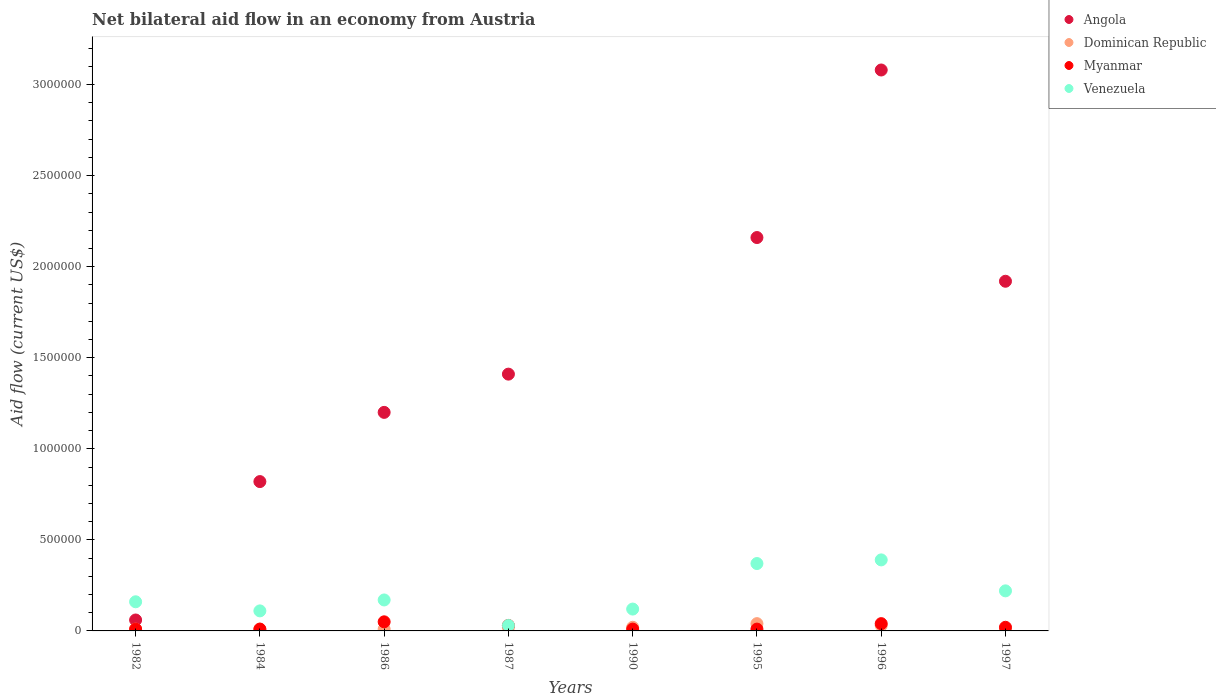Is the number of dotlines equal to the number of legend labels?
Give a very brief answer. No. What is the net bilateral aid flow in Venezuela in 1997?
Give a very brief answer. 2.20e+05. What is the total net bilateral aid flow in Myanmar in the graph?
Offer a terse response. 1.80e+05. What is the difference between the net bilateral aid flow in Angola in 1987 and that in 1997?
Give a very brief answer. -5.10e+05. What is the difference between the net bilateral aid flow in Dominican Republic in 1995 and the net bilateral aid flow in Angola in 1996?
Provide a succinct answer. -3.04e+06. What is the average net bilateral aid flow in Dominican Republic per year?
Offer a terse response. 1.88e+04. In the year 1984, what is the difference between the net bilateral aid flow in Dominican Republic and net bilateral aid flow in Angola?
Provide a short and direct response. -8.10e+05. In how many years, is the net bilateral aid flow in Angola greater than 2400000 US$?
Provide a succinct answer. 1. What is the ratio of the net bilateral aid flow in Angola in 1995 to that in 1996?
Your answer should be compact. 0.7. What is the difference between the highest and the second highest net bilateral aid flow in Myanmar?
Provide a succinct answer. 10000. What is the difference between the highest and the lowest net bilateral aid flow in Venezuela?
Ensure brevity in your answer.  3.60e+05. Is it the case that in every year, the sum of the net bilateral aid flow in Venezuela and net bilateral aid flow in Angola  is greater than the net bilateral aid flow in Dominican Republic?
Your answer should be compact. Yes. How many dotlines are there?
Ensure brevity in your answer.  4. Does the graph contain any zero values?
Provide a short and direct response. Yes. How are the legend labels stacked?
Your response must be concise. Vertical. What is the title of the graph?
Offer a terse response. Net bilateral aid flow in an economy from Austria. What is the label or title of the X-axis?
Your answer should be compact. Years. What is the label or title of the Y-axis?
Your response must be concise. Aid flow (current US$). What is the Aid flow (current US$) in Angola in 1982?
Provide a succinct answer. 6.00e+04. What is the Aid flow (current US$) in Dominican Republic in 1982?
Give a very brief answer. 10000. What is the Aid flow (current US$) of Venezuela in 1982?
Offer a very short reply. 1.60e+05. What is the Aid flow (current US$) in Angola in 1984?
Offer a terse response. 8.20e+05. What is the Aid flow (current US$) in Dominican Republic in 1984?
Your response must be concise. 10000. What is the Aid flow (current US$) in Angola in 1986?
Provide a succinct answer. 1.20e+06. What is the Aid flow (current US$) of Dominican Republic in 1986?
Provide a short and direct response. 10000. What is the Aid flow (current US$) of Myanmar in 1986?
Make the answer very short. 5.00e+04. What is the Aid flow (current US$) of Angola in 1987?
Your answer should be compact. 1.41e+06. What is the Aid flow (current US$) in Myanmar in 1987?
Keep it short and to the point. 3.00e+04. What is the Aid flow (current US$) in Venezuela in 1987?
Give a very brief answer. 3.00e+04. What is the Aid flow (current US$) in Angola in 1990?
Ensure brevity in your answer.  0. What is the Aid flow (current US$) in Venezuela in 1990?
Your answer should be very brief. 1.20e+05. What is the Aid flow (current US$) in Angola in 1995?
Offer a terse response. 2.16e+06. What is the Aid flow (current US$) of Angola in 1996?
Provide a succinct answer. 3.08e+06. What is the Aid flow (current US$) of Dominican Republic in 1996?
Make the answer very short. 3.00e+04. What is the Aid flow (current US$) in Myanmar in 1996?
Your answer should be compact. 4.00e+04. What is the Aid flow (current US$) in Angola in 1997?
Your answer should be very brief. 1.92e+06. What is the Aid flow (current US$) of Myanmar in 1997?
Your answer should be very brief. 2.00e+04. Across all years, what is the maximum Aid flow (current US$) of Angola?
Give a very brief answer. 3.08e+06. Across all years, what is the maximum Aid flow (current US$) in Myanmar?
Give a very brief answer. 5.00e+04. Across all years, what is the minimum Aid flow (current US$) of Dominican Republic?
Provide a succinct answer. 10000. What is the total Aid flow (current US$) in Angola in the graph?
Your response must be concise. 1.06e+07. What is the total Aid flow (current US$) of Dominican Republic in the graph?
Make the answer very short. 1.50e+05. What is the total Aid flow (current US$) of Venezuela in the graph?
Give a very brief answer. 1.57e+06. What is the difference between the Aid flow (current US$) of Angola in 1982 and that in 1984?
Make the answer very short. -7.60e+05. What is the difference between the Aid flow (current US$) in Dominican Republic in 1982 and that in 1984?
Offer a terse response. 0. What is the difference between the Aid flow (current US$) in Myanmar in 1982 and that in 1984?
Provide a short and direct response. 0. What is the difference between the Aid flow (current US$) in Venezuela in 1982 and that in 1984?
Offer a very short reply. 5.00e+04. What is the difference between the Aid flow (current US$) of Angola in 1982 and that in 1986?
Offer a very short reply. -1.14e+06. What is the difference between the Aid flow (current US$) in Dominican Republic in 1982 and that in 1986?
Your response must be concise. 0. What is the difference between the Aid flow (current US$) in Venezuela in 1982 and that in 1986?
Give a very brief answer. -10000. What is the difference between the Aid flow (current US$) in Angola in 1982 and that in 1987?
Your answer should be compact. -1.35e+06. What is the difference between the Aid flow (current US$) of Dominican Republic in 1982 and that in 1987?
Ensure brevity in your answer.  -10000. What is the difference between the Aid flow (current US$) in Venezuela in 1982 and that in 1987?
Your answer should be very brief. 1.30e+05. What is the difference between the Aid flow (current US$) in Venezuela in 1982 and that in 1990?
Your answer should be very brief. 4.00e+04. What is the difference between the Aid flow (current US$) in Angola in 1982 and that in 1995?
Your answer should be very brief. -2.10e+06. What is the difference between the Aid flow (current US$) of Myanmar in 1982 and that in 1995?
Give a very brief answer. 0. What is the difference between the Aid flow (current US$) of Angola in 1982 and that in 1996?
Your answer should be very brief. -3.02e+06. What is the difference between the Aid flow (current US$) in Dominican Republic in 1982 and that in 1996?
Give a very brief answer. -2.00e+04. What is the difference between the Aid flow (current US$) in Venezuela in 1982 and that in 1996?
Ensure brevity in your answer.  -2.30e+05. What is the difference between the Aid flow (current US$) in Angola in 1982 and that in 1997?
Give a very brief answer. -1.86e+06. What is the difference between the Aid flow (current US$) in Angola in 1984 and that in 1986?
Provide a short and direct response. -3.80e+05. What is the difference between the Aid flow (current US$) of Dominican Republic in 1984 and that in 1986?
Offer a very short reply. 0. What is the difference between the Aid flow (current US$) of Myanmar in 1984 and that in 1986?
Your answer should be compact. -4.00e+04. What is the difference between the Aid flow (current US$) of Angola in 1984 and that in 1987?
Offer a terse response. -5.90e+05. What is the difference between the Aid flow (current US$) of Dominican Republic in 1984 and that in 1987?
Ensure brevity in your answer.  -10000. What is the difference between the Aid flow (current US$) of Myanmar in 1984 and that in 1987?
Offer a very short reply. -2.00e+04. What is the difference between the Aid flow (current US$) of Angola in 1984 and that in 1995?
Your answer should be compact. -1.34e+06. What is the difference between the Aid flow (current US$) in Dominican Republic in 1984 and that in 1995?
Ensure brevity in your answer.  -3.00e+04. What is the difference between the Aid flow (current US$) of Venezuela in 1984 and that in 1995?
Your response must be concise. -2.60e+05. What is the difference between the Aid flow (current US$) of Angola in 1984 and that in 1996?
Ensure brevity in your answer.  -2.26e+06. What is the difference between the Aid flow (current US$) of Venezuela in 1984 and that in 1996?
Your response must be concise. -2.80e+05. What is the difference between the Aid flow (current US$) in Angola in 1984 and that in 1997?
Your answer should be very brief. -1.10e+06. What is the difference between the Aid flow (current US$) in Dominican Republic in 1984 and that in 1997?
Your response must be concise. 0. What is the difference between the Aid flow (current US$) of Dominican Republic in 1986 and that in 1987?
Your response must be concise. -10000. What is the difference between the Aid flow (current US$) in Myanmar in 1986 and that in 1987?
Provide a short and direct response. 2.00e+04. What is the difference between the Aid flow (current US$) in Venezuela in 1986 and that in 1990?
Your answer should be very brief. 5.00e+04. What is the difference between the Aid flow (current US$) in Angola in 1986 and that in 1995?
Your answer should be very brief. -9.60e+05. What is the difference between the Aid flow (current US$) of Angola in 1986 and that in 1996?
Give a very brief answer. -1.88e+06. What is the difference between the Aid flow (current US$) of Dominican Republic in 1986 and that in 1996?
Your answer should be compact. -2.00e+04. What is the difference between the Aid flow (current US$) in Angola in 1986 and that in 1997?
Your answer should be very brief. -7.20e+05. What is the difference between the Aid flow (current US$) of Dominican Republic in 1987 and that in 1990?
Ensure brevity in your answer.  0. What is the difference between the Aid flow (current US$) of Myanmar in 1987 and that in 1990?
Provide a short and direct response. 2.00e+04. What is the difference between the Aid flow (current US$) in Venezuela in 1987 and that in 1990?
Give a very brief answer. -9.00e+04. What is the difference between the Aid flow (current US$) of Angola in 1987 and that in 1995?
Provide a short and direct response. -7.50e+05. What is the difference between the Aid flow (current US$) in Dominican Republic in 1987 and that in 1995?
Provide a short and direct response. -2.00e+04. What is the difference between the Aid flow (current US$) of Myanmar in 1987 and that in 1995?
Provide a succinct answer. 2.00e+04. What is the difference between the Aid flow (current US$) in Venezuela in 1987 and that in 1995?
Offer a very short reply. -3.40e+05. What is the difference between the Aid flow (current US$) in Angola in 1987 and that in 1996?
Give a very brief answer. -1.67e+06. What is the difference between the Aid flow (current US$) of Dominican Republic in 1987 and that in 1996?
Give a very brief answer. -10000. What is the difference between the Aid flow (current US$) in Venezuela in 1987 and that in 1996?
Your answer should be very brief. -3.60e+05. What is the difference between the Aid flow (current US$) of Angola in 1987 and that in 1997?
Your answer should be very brief. -5.10e+05. What is the difference between the Aid flow (current US$) of Dominican Republic in 1990 and that in 1995?
Offer a terse response. -2.00e+04. What is the difference between the Aid flow (current US$) in Myanmar in 1990 and that in 1995?
Offer a terse response. 0. What is the difference between the Aid flow (current US$) in Venezuela in 1990 and that in 1996?
Your response must be concise. -2.70e+05. What is the difference between the Aid flow (current US$) in Myanmar in 1990 and that in 1997?
Give a very brief answer. -10000. What is the difference between the Aid flow (current US$) of Venezuela in 1990 and that in 1997?
Your response must be concise. -1.00e+05. What is the difference between the Aid flow (current US$) in Angola in 1995 and that in 1996?
Make the answer very short. -9.20e+05. What is the difference between the Aid flow (current US$) of Dominican Republic in 1995 and that in 1996?
Offer a very short reply. 10000. What is the difference between the Aid flow (current US$) of Myanmar in 1995 and that in 1996?
Ensure brevity in your answer.  -3.00e+04. What is the difference between the Aid flow (current US$) in Venezuela in 1995 and that in 1996?
Provide a succinct answer. -2.00e+04. What is the difference between the Aid flow (current US$) of Dominican Republic in 1995 and that in 1997?
Give a very brief answer. 3.00e+04. What is the difference between the Aid flow (current US$) in Angola in 1996 and that in 1997?
Ensure brevity in your answer.  1.16e+06. What is the difference between the Aid flow (current US$) of Venezuela in 1996 and that in 1997?
Your answer should be compact. 1.70e+05. What is the difference between the Aid flow (current US$) in Angola in 1982 and the Aid flow (current US$) in Dominican Republic in 1984?
Your answer should be very brief. 5.00e+04. What is the difference between the Aid flow (current US$) in Angola in 1982 and the Aid flow (current US$) in Myanmar in 1984?
Provide a succinct answer. 5.00e+04. What is the difference between the Aid flow (current US$) in Myanmar in 1982 and the Aid flow (current US$) in Venezuela in 1984?
Offer a terse response. -1.00e+05. What is the difference between the Aid flow (current US$) of Angola in 1982 and the Aid flow (current US$) of Dominican Republic in 1986?
Provide a short and direct response. 5.00e+04. What is the difference between the Aid flow (current US$) in Angola in 1982 and the Aid flow (current US$) in Myanmar in 1986?
Your response must be concise. 10000. What is the difference between the Aid flow (current US$) in Dominican Republic in 1982 and the Aid flow (current US$) in Myanmar in 1986?
Provide a short and direct response. -4.00e+04. What is the difference between the Aid flow (current US$) in Angola in 1982 and the Aid flow (current US$) in Venezuela in 1987?
Provide a short and direct response. 3.00e+04. What is the difference between the Aid flow (current US$) in Dominican Republic in 1982 and the Aid flow (current US$) in Venezuela in 1987?
Provide a succinct answer. -2.00e+04. What is the difference between the Aid flow (current US$) in Myanmar in 1982 and the Aid flow (current US$) in Venezuela in 1987?
Provide a short and direct response. -2.00e+04. What is the difference between the Aid flow (current US$) in Angola in 1982 and the Aid flow (current US$) in Dominican Republic in 1990?
Keep it short and to the point. 4.00e+04. What is the difference between the Aid flow (current US$) in Angola in 1982 and the Aid flow (current US$) in Myanmar in 1990?
Your answer should be compact. 5.00e+04. What is the difference between the Aid flow (current US$) in Angola in 1982 and the Aid flow (current US$) in Venezuela in 1990?
Give a very brief answer. -6.00e+04. What is the difference between the Aid flow (current US$) of Angola in 1982 and the Aid flow (current US$) of Dominican Republic in 1995?
Provide a succinct answer. 2.00e+04. What is the difference between the Aid flow (current US$) of Angola in 1982 and the Aid flow (current US$) of Myanmar in 1995?
Offer a very short reply. 5.00e+04. What is the difference between the Aid flow (current US$) of Angola in 1982 and the Aid flow (current US$) of Venezuela in 1995?
Your response must be concise. -3.10e+05. What is the difference between the Aid flow (current US$) in Dominican Republic in 1982 and the Aid flow (current US$) in Myanmar in 1995?
Your answer should be compact. 0. What is the difference between the Aid flow (current US$) in Dominican Republic in 1982 and the Aid flow (current US$) in Venezuela in 1995?
Provide a succinct answer. -3.60e+05. What is the difference between the Aid flow (current US$) in Myanmar in 1982 and the Aid flow (current US$) in Venezuela in 1995?
Your answer should be compact. -3.60e+05. What is the difference between the Aid flow (current US$) of Angola in 1982 and the Aid flow (current US$) of Dominican Republic in 1996?
Ensure brevity in your answer.  3.00e+04. What is the difference between the Aid flow (current US$) of Angola in 1982 and the Aid flow (current US$) of Venezuela in 1996?
Give a very brief answer. -3.30e+05. What is the difference between the Aid flow (current US$) of Dominican Republic in 1982 and the Aid flow (current US$) of Venezuela in 1996?
Ensure brevity in your answer.  -3.80e+05. What is the difference between the Aid flow (current US$) of Myanmar in 1982 and the Aid flow (current US$) of Venezuela in 1996?
Your response must be concise. -3.80e+05. What is the difference between the Aid flow (current US$) in Angola in 1982 and the Aid flow (current US$) in Dominican Republic in 1997?
Your response must be concise. 5.00e+04. What is the difference between the Aid flow (current US$) in Angola in 1982 and the Aid flow (current US$) in Venezuela in 1997?
Keep it short and to the point. -1.60e+05. What is the difference between the Aid flow (current US$) of Myanmar in 1982 and the Aid flow (current US$) of Venezuela in 1997?
Keep it short and to the point. -2.10e+05. What is the difference between the Aid flow (current US$) in Angola in 1984 and the Aid flow (current US$) in Dominican Republic in 1986?
Make the answer very short. 8.10e+05. What is the difference between the Aid flow (current US$) in Angola in 1984 and the Aid flow (current US$) in Myanmar in 1986?
Offer a terse response. 7.70e+05. What is the difference between the Aid flow (current US$) of Angola in 1984 and the Aid flow (current US$) of Venezuela in 1986?
Offer a very short reply. 6.50e+05. What is the difference between the Aid flow (current US$) in Dominican Republic in 1984 and the Aid flow (current US$) in Myanmar in 1986?
Ensure brevity in your answer.  -4.00e+04. What is the difference between the Aid flow (current US$) in Dominican Republic in 1984 and the Aid flow (current US$) in Venezuela in 1986?
Ensure brevity in your answer.  -1.60e+05. What is the difference between the Aid flow (current US$) in Myanmar in 1984 and the Aid flow (current US$) in Venezuela in 1986?
Offer a very short reply. -1.60e+05. What is the difference between the Aid flow (current US$) of Angola in 1984 and the Aid flow (current US$) of Myanmar in 1987?
Provide a succinct answer. 7.90e+05. What is the difference between the Aid flow (current US$) in Angola in 1984 and the Aid flow (current US$) in Venezuela in 1987?
Your answer should be compact. 7.90e+05. What is the difference between the Aid flow (current US$) in Dominican Republic in 1984 and the Aid flow (current US$) in Venezuela in 1987?
Provide a short and direct response. -2.00e+04. What is the difference between the Aid flow (current US$) of Angola in 1984 and the Aid flow (current US$) of Dominican Republic in 1990?
Keep it short and to the point. 8.00e+05. What is the difference between the Aid flow (current US$) of Angola in 1984 and the Aid flow (current US$) of Myanmar in 1990?
Provide a succinct answer. 8.10e+05. What is the difference between the Aid flow (current US$) in Angola in 1984 and the Aid flow (current US$) in Venezuela in 1990?
Your answer should be compact. 7.00e+05. What is the difference between the Aid flow (current US$) in Dominican Republic in 1984 and the Aid flow (current US$) in Myanmar in 1990?
Your answer should be very brief. 0. What is the difference between the Aid flow (current US$) of Angola in 1984 and the Aid flow (current US$) of Dominican Republic in 1995?
Provide a short and direct response. 7.80e+05. What is the difference between the Aid flow (current US$) in Angola in 1984 and the Aid flow (current US$) in Myanmar in 1995?
Give a very brief answer. 8.10e+05. What is the difference between the Aid flow (current US$) of Dominican Republic in 1984 and the Aid flow (current US$) of Myanmar in 1995?
Offer a very short reply. 0. What is the difference between the Aid flow (current US$) in Dominican Republic in 1984 and the Aid flow (current US$) in Venezuela in 1995?
Your answer should be compact. -3.60e+05. What is the difference between the Aid flow (current US$) of Myanmar in 1984 and the Aid flow (current US$) of Venezuela in 1995?
Your response must be concise. -3.60e+05. What is the difference between the Aid flow (current US$) of Angola in 1984 and the Aid flow (current US$) of Dominican Republic in 1996?
Provide a succinct answer. 7.90e+05. What is the difference between the Aid flow (current US$) of Angola in 1984 and the Aid flow (current US$) of Myanmar in 1996?
Your answer should be compact. 7.80e+05. What is the difference between the Aid flow (current US$) in Dominican Republic in 1984 and the Aid flow (current US$) in Myanmar in 1996?
Give a very brief answer. -3.00e+04. What is the difference between the Aid flow (current US$) in Dominican Republic in 1984 and the Aid flow (current US$) in Venezuela in 1996?
Ensure brevity in your answer.  -3.80e+05. What is the difference between the Aid flow (current US$) of Myanmar in 1984 and the Aid flow (current US$) of Venezuela in 1996?
Give a very brief answer. -3.80e+05. What is the difference between the Aid flow (current US$) in Angola in 1984 and the Aid flow (current US$) in Dominican Republic in 1997?
Give a very brief answer. 8.10e+05. What is the difference between the Aid flow (current US$) of Angola in 1984 and the Aid flow (current US$) of Myanmar in 1997?
Offer a very short reply. 8.00e+05. What is the difference between the Aid flow (current US$) of Angola in 1984 and the Aid flow (current US$) of Venezuela in 1997?
Offer a very short reply. 6.00e+05. What is the difference between the Aid flow (current US$) in Angola in 1986 and the Aid flow (current US$) in Dominican Republic in 1987?
Offer a terse response. 1.18e+06. What is the difference between the Aid flow (current US$) in Angola in 1986 and the Aid flow (current US$) in Myanmar in 1987?
Your answer should be compact. 1.17e+06. What is the difference between the Aid flow (current US$) of Angola in 1986 and the Aid flow (current US$) of Venezuela in 1987?
Keep it short and to the point. 1.17e+06. What is the difference between the Aid flow (current US$) of Dominican Republic in 1986 and the Aid flow (current US$) of Venezuela in 1987?
Keep it short and to the point. -2.00e+04. What is the difference between the Aid flow (current US$) of Myanmar in 1986 and the Aid flow (current US$) of Venezuela in 1987?
Make the answer very short. 2.00e+04. What is the difference between the Aid flow (current US$) of Angola in 1986 and the Aid flow (current US$) of Dominican Republic in 1990?
Keep it short and to the point. 1.18e+06. What is the difference between the Aid flow (current US$) in Angola in 1986 and the Aid flow (current US$) in Myanmar in 1990?
Keep it short and to the point. 1.19e+06. What is the difference between the Aid flow (current US$) of Angola in 1986 and the Aid flow (current US$) of Venezuela in 1990?
Your answer should be compact. 1.08e+06. What is the difference between the Aid flow (current US$) in Dominican Republic in 1986 and the Aid flow (current US$) in Myanmar in 1990?
Your answer should be compact. 0. What is the difference between the Aid flow (current US$) of Angola in 1986 and the Aid flow (current US$) of Dominican Republic in 1995?
Give a very brief answer. 1.16e+06. What is the difference between the Aid flow (current US$) in Angola in 1986 and the Aid flow (current US$) in Myanmar in 1995?
Your answer should be very brief. 1.19e+06. What is the difference between the Aid flow (current US$) in Angola in 1986 and the Aid flow (current US$) in Venezuela in 1995?
Offer a terse response. 8.30e+05. What is the difference between the Aid flow (current US$) in Dominican Republic in 1986 and the Aid flow (current US$) in Myanmar in 1995?
Ensure brevity in your answer.  0. What is the difference between the Aid flow (current US$) in Dominican Republic in 1986 and the Aid flow (current US$) in Venezuela in 1995?
Ensure brevity in your answer.  -3.60e+05. What is the difference between the Aid flow (current US$) in Myanmar in 1986 and the Aid flow (current US$) in Venezuela in 1995?
Offer a terse response. -3.20e+05. What is the difference between the Aid flow (current US$) of Angola in 1986 and the Aid flow (current US$) of Dominican Republic in 1996?
Your response must be concise. 1.17e+06. What is the difference between the Aid flow (current US$) of Angola in 1986 and the Aid flow (current US$) of Myanmar in 1996?
Your answer should be very brief. 1.16e+06. What is the difference between the Aid flow (current US$) in Angola in 1986 and the Aid flow (current US$) in Venezuela in 1996?
Ensure brevity in your answer.  8.10e+05. What is the difference between the Aid flow (current US$) in Dominican Republic in 1986 and the Aid flow (current US$) in Myanmar in 1996?
Give a very brief answer. -3.00e+04. What is the difference between the Aid flow (current US$) in Dominican Republic in 1986 and the Aid flow (current US$) in Venezuela in 1996?
Offer a very short reply. -3.80e+05. What is the difference between the Aid flow (current US$) in Myanmar in 1986 and the Aid flow (current US$) in Venezuela in 1996?
Your answer should be compact. -3.40e+05. What is the difference between the Aid flow (current US$) of Angola in 1986 and the Aid flow (current US$) of Dominican Republic in 1997?
Keep it short and to the point. 1.19e+06. What is the difference between the Aid flow (current US$) in Angola in 1986 and the Aid flow (current US$) in Myanmar in 1997?
Your answer should be very brief. 1.18e+06. What is the difference between the Aid flow (current US$) of Angola in 1986 and the Aid flow (current US$) of Venezuela in 1997?
Provide a succinct answer. 9.80e+05. What is the difference between the Aid flow (current US$) of Dominican Republic in 1986 and the Aid flow (current US$) of Myanmar in 1997?
Offer a terse response. -10000. What is the difference between the Aid flow (current US$) of Angola in 1987 and the Aid flow (current US$) of Dominican Republic in 1990?
Your answer should be very brief. 1.39e+06. What is the difference between the Aid flow (current US$) of Angola in 1987 and the Aid flow (current US$) of Myanmar in 1990?
Your answer should be compact. 1.40e+06. What is the difference between the Aid flow (current US$) in Angola in 1987 and the Aid flow (current US$) in Venezuela in 1990?
Make the answer very short. 1.29e+06. What is the difference between the Aid flow (current US$) of Angola in 1987 and the Aid flow (current US$) of Dominican Republic in 1995?
Ensure brevity in your answer.  1.37e+06. What is the difference between the Aid flow (current US$) in Angola in 1987 and the Aid flow (current US$) in Myanmar in 1995?
Give a very brief answer. 1.40e+06. What is the difference between the Aid flow (current US$) in Angola in 1987 and the Aid flow (current US$) in Venezuela in 1995?
Ensure brevity in your answer.  1.04e+06. What is the difference between the Aid flow (current US$) in Dominican Republic in 1987 and the Aid flow (current US$) in Venezuela in 1995?
Keep it short and to the point. -3.50e+05. What is the difference between the Aid flow (current US$) of Myanmar in 1987 and the Aid flow (current US$) of Venezuela in 1995?
Your answer should be compact. -3.40e+05. What is the difference between the Aid flow (current US$) in Angola in 1987 and the Aid flow (current US$) in Dominican Republic in 1996?
Give a very brief answer. 1.38e+06. What is the difference between the Aid flow (current US$) in Angola in 1987 and the Aid flow (current US$) in Myanmar in 1996?
Provide a short and direct response. 1.37e+06. What is the difference between the Aid flow (current US$) of Angola in 1987 and the Aid flow (current US$) of Venezuela in 1996?
Your response must be concise. 1.02e+06. What is the difference between the Aid flow (current US$) of Dominican Republic in 1987 and the Aid flow (current US$) of Venezuela in 1996?
Provide a short and direct response. -3.70e+05. What is the difference between the Aid flow (current US$) of Myanmar in 1987 and the Aid flow (current US$) of Venezuela in 1996?
Make the answer very short. -3.60e+05. What is the difference between the Aid flow (current US$) of Angola in 1987 and the Aid flow (current US$) of Dominican Republic in 1997?
Your response must be concise. 1.40e+06. What is the difference between the Aid flow (current US$) in Angola in 1987 and the Aid flow (current US$) in Myanmar in 1997?
Your answer should be very brief. 1.39e+06. What is the difference between the Aid flow (current US$) in Angola in 1987 and the Aid flow (current US$) in Venezuela in 1997?
Keep it short and to the point. 1.19e+06. What is the difference between the Aid flow (current US$) of Dominican Republic in 1987 and the Aid flow (current US$) of Myanmar in 1997?
Provide a succinct answer. 0. What is the difference between the Aid flow (current US$) of Dominican Republic in 1987 and the Aid flow (current US$) of Venezuela in 1997?
Ensure brevity in your answer.  -2.00e+05. What is the difference between the Aid flow (current US$) of Myanmar in 1987 and the Aid flow (current US$) of Venezuela in 1997?
Give a very brief answer. -1.90e+05. What is the difference between the Aid flow (current US$) in Dominican Republic in 1990 and the Aid flow (current US$) in Myanmar in 1995?
Give a very brief answer. 10000. What is the difference between the Aid flow (current US$) in Dominican Republic in 1990 and the Aid flow (current US$) in Venezuela in 1995?
Keep it short and to the point. -3.50e+05. What is the difference between the Aid flow (current US$) in Myanmar in 1990 and the Aid flow (current US$) in Venezuela in 1995?
Your answer should be compact. -3.60e+05. What is the difference between the Aid flow (current US$) in Dominican Republic in 1990 and the Aid flow (current US$) in Myanmar in 1996?
Provide a succinct answer. -2.00e+04. What is the difference between the Aid flow (current US$) in Dominican Republic in 1990 and the Aid flow (current US$) in Venezuela in 1996?
Offer a terse response. -3.70e+05. What is the difference between the Aid flow (current US$) in Myanmar in 1990 and the Aid flow (current US$) in Venezuela in 1996?
Make the answer very short. -3.80e+05. What is the difference between the Aid flow (current US$) of Dominican Republic in 1990 and the Aid flow (current US$) of Venezuela in 1997?
Make the answer very short. -2.00e+05. What is the difference between the Aid flow (current US$) of Myanmar in 1990 and the Aid flow (current US$) of Venezuela in 1997?
Offer a terse response. -2.10e+05. What is the difference between the Aid flow (current US$) of Angola in 1995 and the Aid flow (current US$) of Dominican Republic in 1996?
Offer a very short reply. 2.13e+06. What is the difference between the Aid flow (current US$) in Angola in 1995 and the Aid flow (current US$) in Myanmar in 1996?
Provide a succinct answer. 2.12e+06. What is the difference between the Aid flow (current US$) in Angola in 1995 and the Aid flow (current US$) in Venezuela in 1996?
Your answer should be compact. 1.77e+06. What is the difference between the Aid flow (current US$) of Dominican Republic in 1995 and the Aid flow (current US$) of Myanmar in 1996?
Provide a short and direct response. 0. What is the difference between the Aid flow (current US$) in Dominican Republic in 1995 and the Aid flow (current US$) in Venezuela in 1996?
Offer a very short reply. -3.50e+05. What is the difference between the Aid flow (current US$) in Myanmar in 1995 and the Aid flow (current US$) in Venezuela in 1996?
Keep it short and to the point. -3.80e+05. What is the difference between the Aid flow (current US$) of Angola in 1995 and the Aid flow (current US$) of Dominican Republic in 1997?
Offer a terse response. 2.15e+06. What is the difference between the Aid flow (current US$) in Angola in 1995 and the Aid flow (current US$) in Myanmar in 1997?
Provide a succinct answer. 2.14e+06. What is the difference between the Aid flow (current US$) in Angola in 1995 and the Aid flow (current US$) in Venezuela in 1997?
Ensure brevity in your answer.  1.94e+06. What is the difference between the Aid flow (current US$) of Dominican Republic in 1995 and the Aid flow (current US$) of Myanmar in 1997?
Offer a very short reply. 2.00e+04. What is the difference between the Aid flow (current US$) in Myanmar in 1995 and the Aid flow (current US$) in Venezuela in 1997?
Your answer should be very brief. -2.10e+05. What is the difference between the Aid flow (current US$) in Angola in 1996 and the Aid flow (current US$) in Dominican Republic in 1997?
Offer a very short reply. 3.07e+06. What is the difference between the Aid flow (current US$) in Angola in 1996 and the Aid flow (current US$) in Myanmar in 1997?
Offer a very short reply. 3.06e+06. What is the difference between the Aid flow (current US$) in Angola in 1996 and the Aid flow (current US$) in Venezuela in 1997?
Keep it short and to the point. 2.86e+06. What is the difference between the Aid flow (current US$) of Dominican Republic in 1996 and the Aid flow (current US$) of Venezuela in 1997?
Offer a terse response. -1.90e+05. What is the difference between the Aid flow (current US$) in Myanmar in 1996 and the Aid flow (current US$) in Venezuela in 1997?
Offer a very short reply. -1.80e+05. What is the average Aid flow (current US$) of Angola per year?
Offer a very short reply. 1.33e+06. What is the average Aid flow (current US$) in Dominican Republic per year?
Offer a very short reply. 1.88e+04. What is the average Aid flow (current US$) in Myanmar per year?
Offer a terse response. 2.25e+04. What is the average Aid flow (current US$) in Venezuela per year?
Keep it short and to the point. 1.96e+05. In the year 1982, what is the difference between the Aid flow (current US$) of Angola and Aid flow (current US$) of Myanmar?
Keep it short and to the point. 5.00e+04. In the year 1984, what is the difference between the Aid flow (current US$) in Angola and Aid flow (current US$) in Dominican Republic?
Offer a terse response. 8.10e+05. In the year 1984, what is the difference between the Aid flow (current US$) of Angola and Aid flow (current US$) of Myanmar?
Offer a terse response. 8.10e+05. In the year 1984, what is the difference between the Aid flow (current US$) in Angola and Aid flow (current US$) in Venezuela?
Offer a very short reply. 7.10e+05. In the year 1984, what is the difference between the Aid flow (current US$) in Dominican Republic and Aid flow (current US$) in Venezuela?
Offer a terse response. -1.00e+05. In the year 1986, what is the difference between the Aid flow (current US$) of Angola and Aid flow (current US$) of Dominican Republic?
Ensure brevity in your answer.  1.19e+06. In the year 1986, what is the difference between the Aid flow (current US$) in Angola and Aid flow (current US$) in Myanmar?
Your answer should be very brief. 1.15e+06. In the year 1986, what is the difference between the Aid flow (current US$) of Angola and Aid flow (current US$) of Venezuela?
Keep it short and to the point. 1.03e+06. In the year 1986, what is the difference between the Aid flow (current US$) of Dominican Republic and Aid flow (current US$) of Myanmar?
Make the answer very short. -4.00e+04. In the year 1986, what is the difference between the Aid flow (current US$) of Dominican Republic and Aid flow (current US$) of Venezuela?
Your answer should be compact. -1.60e+05. In the year 1986, what is the difference between the Aid flow (current US$) in Myanmar and Aid flow (current US$) in Venezuela?
Offer a terse response. -1.20e+05. In the year 1987, what is the difference between the Aid flow (current US$) in Angola and Aid flow (current US$) in Dominican Republic?
Make the answer very short. 1.39e+06. In the year 1987, what is the difference between the Aid flow (current US$) in Angola and Aid flow (current US$) in Myanmar?
Provide a succinct answer. 1.38e+06. In the year 1987, what is the difference between the Aid flow (current US$) of Angola and Aid flow (current US$) of Venezuela?
Ensure brevity in your answer.  1.38e+06. In the year 1987, what is the difference between the Aid flow (current US$) of Myanmar and Aid flow (current US$) of Venezuela?
Make the answer very short. 0. In the year 1990, what is the difference between the Aid flow (current US$) in Dominican Republic and Aid flow (current US$) in Myanmar?
Make the answer very short. 10000. In the year 1990, what is the difference between the Aid flow (current US$) of Dominican Republic and Aid flow (current US$) of Venezuela?
Make the answer very short. -1.00e+05. In the year 1990, what is the difference between the Aid flow (current US$) in Myanmar and Aid flow (current US$) in Venezuela?
Give a very brief answer. -1.10e+05. In the year 1995, what is the difference between the Aid flow (current US$) in Angola and Aid flow (current US$) in Dominican Republic?
Your answer should be compact. 2.12e+06. In the year 1995, what is the difference between the Aid flow (current US$) in Angola and Aid flow (current US$) in Myanmar?
Your response must be concise. 2.15e+06. In the year 1995, what is the difference between the Aid flow (current US$) of Angola and Aid flow (current US$) of Venezuela?
Provide a short and direct response. 1.79e+06. In the year 1995, what is the difference between the Aid flow (current US$) of Dominican Republic and Aid flow (current US$) of Myanmar?
Your response must be concise. 3.00e+04. In the year 1995, what is the difference between the Aid flow (current US$) of Dominican Republic and Aid flow (current US$) of Venezuela?
Your response must be concise. -3.30e+05. In the year 1995, what is the difference between the Aid flow (current US$) of Myanmar and Aid flow (current US$) of Venezuela?
Give a very brief answer. -3.60e+05. In the year 1996, what is the difference between the Aid flow (current US$) in Angola and Aid flow (current US$) in Dominican Republic?
Provide a short and direct response. 3.05e+06. In the year 1996, what is the difference between the Aid flow (current US$) of Angola and Aid flow (current US$) of Myanmar?
Provide a short and direct response. 3.04e+06. In the year 1996, what is the difference between the Aid flow (current US$) of Angola and Aid flow (current US$) of Venezuela?
Provide a short and direct response. 2.69e+06. In the year 1996, what is the difference between the Aid flow (current US$) in Dominican Republic and Aid flow (current US$) in Myanmar?
Offer a very short reply. -10000. In the year 1996, what is the difference between the Aid flow (current US$) in Dominican Republic and Aid flow (current US$) in Venezuela?
Offer a terse response. -3.60e+05. In the year 1996, what is the difference between the Aid flow (current US$) in Myanmar and Aid flow (current US$) in Venezuela?
Offer a very short reply. -3.50e+05. In the year 1997, what is the difference between the Aid flow (current US$) in Angola and Aid flow (current US$) in Dominican Republic?
Offer a terse response. 1.91e+06. In the year 1997, what is the difference between the Aid flow (current US$) in Angola and Aid flow (current US$) in Myanmar?
Give a very brief answer. 1.90e+06. In the year 1997, what is the difference between the Aid flow (current US$) in Angola and Aid flow (current US$) in Venezuela?
Your response must be concise. 1.70e+06. In the year 1997, what is the difference between the Aid flow (current US$) in Dominican Republic and Aid flow (current US$) in Venezuela?
Your answer should be very brief. -2.10e+05. In the year 1997, what is the difference between the Aid flow (current US$) in Myanmar and Aid flow (current US$) in Venezuela?
Your answer should be very brief. -2.00e+05. What is the ratio of the Aid flow (current US$) in Angola in 1982 to that in 1984?
Give a very brief answer. 0.07. What is the ratio of the Aid flow (current US$) of Dominican Republic in 1982 to that in 1984?
Your answer should be compact. 1. What is the ratio of the Aid flow (current US$) of Myanmar in 1982 to that in 1984?
Offer a terse response. 1. What is the ratio of the Aid flow (current US$) in Venezuela in 1982 to that in 1984?
Ensure brevity in your answer.  1.45. What is the ratio of the Aid flow (current US$) of Angola in 1982 to that in 1986?
Ensure brevity in your answer.  0.05. What is the ratio of the Aid flow (current US$) in Dominican Republic in 1982 to that in 1986?
Your answer should be compact. 1. What is the ratio of the Aid flow (current US$) in Angola in 1982 to that in 1987?
Your response must be concise. 0.04. What is the ratio of the Aid flow (current US$) in Venezuela in 1982 to that in 1987?
Ensure brevity in your answer.  5.33. What is the ratio of the Aid flow (current US$) of Dominican Republic in 1982 to that in 1990?
Provide a succinct answer. 0.5. What is the ratio of the Aid flow (current US$) of Angola in 1982 to that in 1995?
Your answer should be very brief. 0.03. What is the ratio of the Aid flow (current US$) of Dominican Republic in 1982 to that in 1995?
Your answer should be compact. 0.25. What is the ratio of the Aid flow (current US$) of Myanmar in 1982 to that in 1995?
Your answer should be compact. 1. What is the ratio of the Aid flow (current US$) in Venezuela in 1982 to that in 1995?
Your answer should be very brief. 0.43. What is the ratio of the Aid flow (current US$) in Angola in 1982 to that in 1996?
Ensure brevity in your answer.  0.02. What is the ratio of the Aid flow (current US$) in Myanmar in 1982 to that in 1996?
Ensure brevity in your answer.  0.25. What is the ratio of the Aid flow (current US$) in Venezuela in 1982 to that in 1996?
Ensure brevity in your answer.  0.41. What is the ratio of the Aid flow (current US$) in Angola in 1982 to that in 1997?
Provide a succinct answer. 0.03. What is the ratio of the Aid flow (current US$) of Myanmar in 1982 to that in 1997?
Your answer should be very brief. 0.5. What is the ratio of the Aid flow (current US$) of Venezuela in 1982 to that in 1997?
Keep it short and to the point. 0.73. What is the ratio of the Aid flow (current US$) of Angola in 1984 to that in 1986?
Your answer should be very brief. 0.68. What is the ratio of the Aid flow (current US$) in Venezuela in 1984 to that in 1986?
Ensure brevity in your answer.  0.65. What is the ratio of the Aid flow (current US$) of Angola in 1984 to that in 1987?
Provide a short and direct response. 0.58. What is the ratio of the Aid flow (current US$) in Dominican Republic in 1984 to that in 1987?
Your answer should be compact. 0.5. What is the ratio of the Aid flow (current US$) of Myanmar in 1984 to that in 1987?
Offer a terse response. 0.33. What is the ratio of the Aid flow (current US$) in Venezuela in 1984 to that in 1987?
Provide a succinct answer. 3.67. What is the ratio of the Aid flow (current US$) in Dominican Republic in 1984 to that in 1990?
Offer a very short reply. 0.5. What is the ratio of the Aid flow (current US$) in Venezuela in 1984 to that in 1990?
Give a very brief answer. 0.92. What is the ratio of the Aid flow (current US$) of Angola in 1984 to that in 1995?
Provide a succinct answer. 0.38. What is the ratio of the Aid flow (current US$) of Dominican Republic in 1984 to that in 1995?
Offer a terse response. 0.25. What is the ratio of the Aid flow (current US$) of Myanmar in 1984 to that in 1995?
Ensure brevity in your answer.  1. What is the ratio of the Aid flow (current US$) of Venezuela in 1984 to that in 1995?
Keep it short and to the point. 0.3. What is the ratio of the Aid flow (current US$) of Angola in 1984 to that in 1996?
Make the answer very short. 0.27. What is the ratio of the Aid flow (current US$) of Dominican Republic in 1984 to that in 1996?
Your answer should be very brief. 0.33. What is the ratio of the Aid flow (current US$) in Venezuela in 1984 to that in 1996?
Your response must be concise. 0.28. What is the ratio of the Aid flow (current US$) of Angola in 1984 to that in 1997?
Your answer should be compact. 0.43. What is the ratio of the Aid flow (current US$) in Dominican Republic in 1984 to that in 1997?
Provide a short and direct response. 1. What is the ratio of the Aid flow (current US$) in Myanmar in 1984 to that in 1997?
Make the answer very short. 0.5. What is the ratio of the Aid flow (current US$) of Angola in 1986 to that in 1987?
Give a very brief answer. 0.85. What is the ratio of the Aid flow (current US$) of Myanmar in 1986 to that in 1987?
Your response must be concise. 1.67. What is the ratio of the Aid flow (current US$) in Venezuela in 1986 to that in 1987?
Offer a terse response. 5.67. What is the ratio of the Aid flow (current US$) in Dominican Republic in 1986 to that in 1990?
Give a very brief answer. 0.5. What is the ratio of the Aid flow (current US$) in Myanmar in 1986 to that in 1990?
Your response must be concise. 5. What is the ratio of the Aid flow (current US$) of Venezuela in 1986 to that in 1990?
Your response must be concise. 1.42. What is the ratio of the Aid flow (current US$) in Angola in 1986 to that in 1995?
Offer a very short reply. 0.56. What is the ratio of the Aid flow (current US$) of Dominican Republic in 1986 to that in 1995?
Provide a short and direct response. 0.25. What is the ratio of the Aid flow (current US$) in Venezuela in 1986 to that in 1995?
Offer a terse response. 0.46. What is the ratio of the Aid flow (current US$) of Angola in 1986 to that in 1996?
Offer a very short reply. 0.39. What is the ratio of the Aid flow (current US$) in Dominican Republic in 1986 to that in 1996?
Your answer should be very brief. 0.33. What is the ratio of the Aid flow (current US$) in Myanmar in 1986 to that in 1996?
Your answer should be compact. 1.25. What is the ratio of the Aid flow (current US$) in Venezuela in 1986 to that in 1996?
Keep it short and to the point. 0.44. What is the ratio of the Aid flow (current US$) in Angola in 1986 to that in 1997?
Make the answer very short. 0.62. What is the ratio of the Aid flow (current US$) of Venezuela in 1986 to that in 1997?
Offer a very short reply. 0.77. What is the ratio of the Aid flow (current US$) of Angola in 1987 to that in 1995?
Ensure brevity in your answer.  0.65. What is the ratio of the Aid flow (current US$) in Myanmar in 1987 to that in 1995?
Make the answer very short. 3. What is the ratio of the Aid flow (current US$) in Venezuela in 1987 to that in 1995?
Your answer should be compact. 0.08. What is the ratio of the Aid flow (current US$) in Angola in 1987 to that in 1996?
Provide a short and direct response. 0.46. What is the ratio of the Aid flow (current US$) of Myanmar in 1987 to that in 1996?
Offer a terse response. 0.75. What is the ratio of the Aid flow (current US$) in Venezuela in 1987 to that in 1996?
Ensure brevity in your answer.  0.08. What is the ratio of the Aid flow (current US$) of Angola in 1987 to that in 1997?
Offer a terse response. 0.73. What is the ratio of the Aid flow (current US$) in Myanmar in 1987 to that in 1997?
Make the answer very short. 1.5. What is the ratio of the Aid flow (current US$) of Venezuela in 1987 to that in 1997?
Keep it short and to the point. 0.14. What is the ratio of the Aid flow (current US$) of Venezuela in 1990 to that in 1995?
Offer a terse response. 0.32. What is the ratio of the Aid flow (current US$) in Venezuela in 1990 to that in 1996?
Your answer should be compact. 0.31. What is the ratio of the Aid flow (current US$) of Venezuela in 1990 to that in 1997?
Keep it short and to the point. 0.55. What is the ratio of the Aid flow (current US$) of Angola in 1995 to that in 1996?
Ensure brevity in your answer.  0.7. What is the ratio of the Aid flow (current US$) of Myanmar in 1995 to that in 1996?
Make the answer very short. 0.25. What is the ratio of the Aid flow (current US$) in Venezuela in 1995 to that in 1996?
Offer a terse response. 0.95. What is the ratio of the Aid flow (current US$) of Myanmar in 1995 to that in 1997?
Give a very brief answer. 0.5. What is the ratio of the Aid flow (current US$) of Venezuela in 1995 to that in 1997?
Keep it short and to the point. 1.68. What is the ratio of the Aid flow (current US$) of Angola in 1996 to that in 1997?
Your answer should be very brief. 1.6. What is the ratio of the Aid flow (current US$) in Myanmar in 1996 to that in 1997?
Your answer should be very brief. 2. What is the ratio of the Aid flow (current US$) of Venezuela in 1996 to that in 1997?
Make the answer very short. 1.77. What is the difference between the highest and the second highest Aid flow (current US$) in Angola?
Keep it short and to the point. 9.20e+05. What is the difference between the highest and the lowest Aid flow (current US$) of Angola?
Offer a very short reply. 3.08e+06. What is the difference between the highest and the lowest Aid flow (current US$) in Dominican Republic?
Your answer should be very brief. 3.00e+04. What is the difference between the highest and the lowest Aid flow (current US$) of Venezuela?
Your response must be concise. 3.60e+05. 